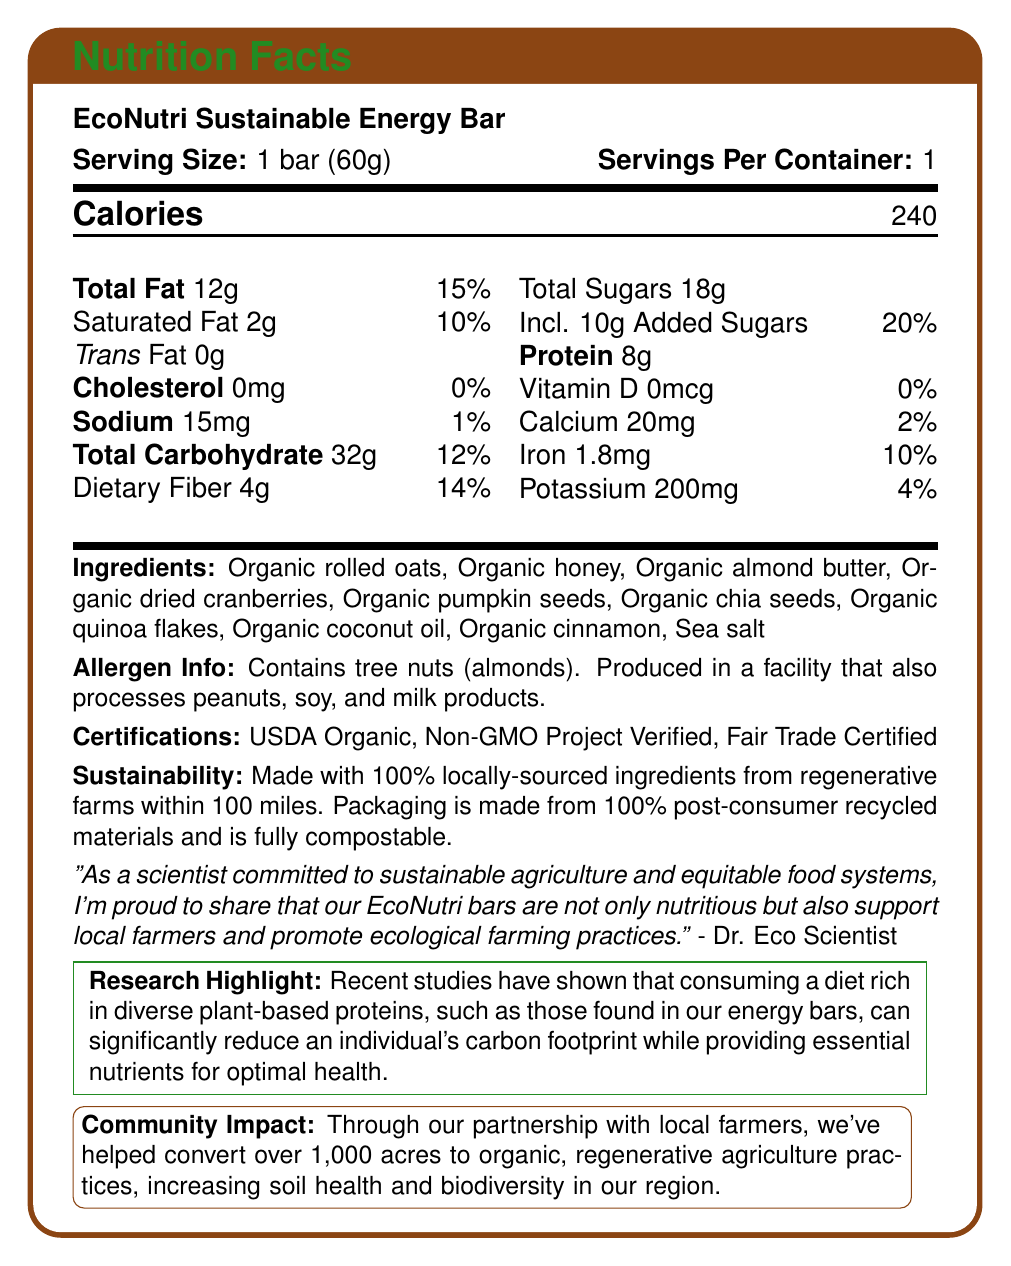what is the serving size for the EcoNutri Sustainable Energy Bar? The document states "Serving Size: 1 bar (60g)".
Answer: 1 bar (60g) how many calories are in one serving of the energy bar? The document lists "Calories: 240".
Answer: 240 what percentage of the daily value of saturated fat does the energy bar contain? The document states "Saturated Fat 2g 10%".
Answer: 10% does the EcoNutri Sustainable Energy Bar contain any trans fat? The document specifies "Trans Fat 0g".
Answer: No list three organic ingredients found in the energy bar. The document lists the ingredients: "Organic rolled oats, Organic honey, Organic almond butter, Organic dried cranberries, Organic pumpkin seeds, Organic chia seeds, Organic quinoa flakes, Organic coconut oil, Organic cinnamon, Sea salt".
Answer: Organic rolled oats, Organic honey, Organic almond butter what are the daily value percentages for calcium and iron? The document lists "Calcium 20mg 2%" and "Iron 1.8mg 10%".
Answer: Calcium: 2%, Iron: 10% which certification does not apply to the EcoNutri Sustainable Energy Bar? A. USDA Organic B. Fair Trade Certified C. Gluten-Free D. Non-GMO Project Verified The document lists certifications: USDA Organic, Non-GMO Project Verified, Fair Trade Certified. Gluten-Free is not listed.
Answer: C. Gluten-Free what is the amount of dietary fiber in the energy bar? A. 2g B. 4g C. 6g D. 8g The document states "Dietary Fiber 4g".
Answer: B. 4g is the EcoNutri Sustainable Energy Bar made with locally-sourced ingredients? The document states, "Made with 100% locally-sourced ingredients from regenerative farms within 100 miles."
Answer: Yes summarize the overall message of the EcoNutri Sustainable Energy Bar's Nutrition Facts label. The document showcases the nutritional content, ingredient list, allergen information, certifications, and sustainability information, highlighting that the product supports local agriculture and sustainable practices.
Answer: The EcoNutri Sustainable Energy Bar is a nutritious energy bar made with organic, locally-sourced ingredients. It contains 240 calories per serving, with a balanced nutrition profile including 12g total fat, 32g total carbohydrates, and 8g protein. The bar is free of cholesterol and trans fat and is rich in dietary fiber. It is certified USDA Organic, Non-GMO Project Verified, and Fair Trade Certified. Additionally, the bar promotes sustainable farming practices and has a significant community impact by supporting local farmers and improving soil health. how does the EcoNutri Sustainable Energy Bar contribute to sustainability? The sustainability section of the document provides details about the local sourcing of ingredients and the eco-friendly packaging.
Answer: It is made with 100% locally-sourced ingredients from regenerative farms within 100 miles, and the packaging is made from 100% post-consumer recycled materials and is fully compostable. what fiber sources are included in the ingredients of the energy bar? These ingredients are listed in the document and are known sources of dietary fiber.
Answer: Organic rolled oats, Organic chia seeds, Organic quinoa flakes does the energy bar contain any added sugars? The document states "Incl. 10g Added Sugars 20%".
Answer: Yes which ingredient in the energy bar is a potential allergen? A. Organic honey B. Organic almond butter C. Organic rolled oats D. Organic quinoa flakes The allergen information states "Contains tree nuts (almonds)".
Answer: B. Organic almond butter what are the benefits of the EcoNutri bars mentioned in the manufacturer statement? The manufacturer statement says, "our EcoNutri bars are not only nutritious but also support local farmers and promote ecological farming practices."
Answer: They support local farmers and promote ecological farming practices. how many servings are there per container of the energy bar? The document states "Servings Per Container: 1".
Answer: 1 how much potassium does the energy bar provide? The document lists "Potassium 200mg 4%".
Answer: 200mg how many acres have been converted to organic, regenerative agriculture through partnerships? The community impact section states "we've helped convert over 1,000 acres to organic, regenerative agriculture practices".
Answer: Over 1,000 acres how many grams of total sugars are in the energy bar? The document lists "Total Sugars 18g".
Answer: 18g what is the name of the individual quoted in the document, and their title or role? The quote attributed to "Dr. Eco Scientist" includes their commitment to sustainable agriculture and equitable food systems.
Answer: Dr. Eco Scientist, Scientist committed to sustainable agriculture and equitable food systems did the studies mentioned find that plant-based proteins can reduce an individual's carbon footprint? The research highlight states that consuming a diet rich in diverse plant-based proteins can significantly reduce an individual's carbon footprint.
Answer: Yes what is the percentage daily value of sodium in the energy bar? The document lists "Sodium 15mg 1%".
Answer: 1% when was the EcoNutri Sustainable Energy Bar introduced to the market? The document does not provide information on when the product was introduced to the market.
Answer: Not enough information 